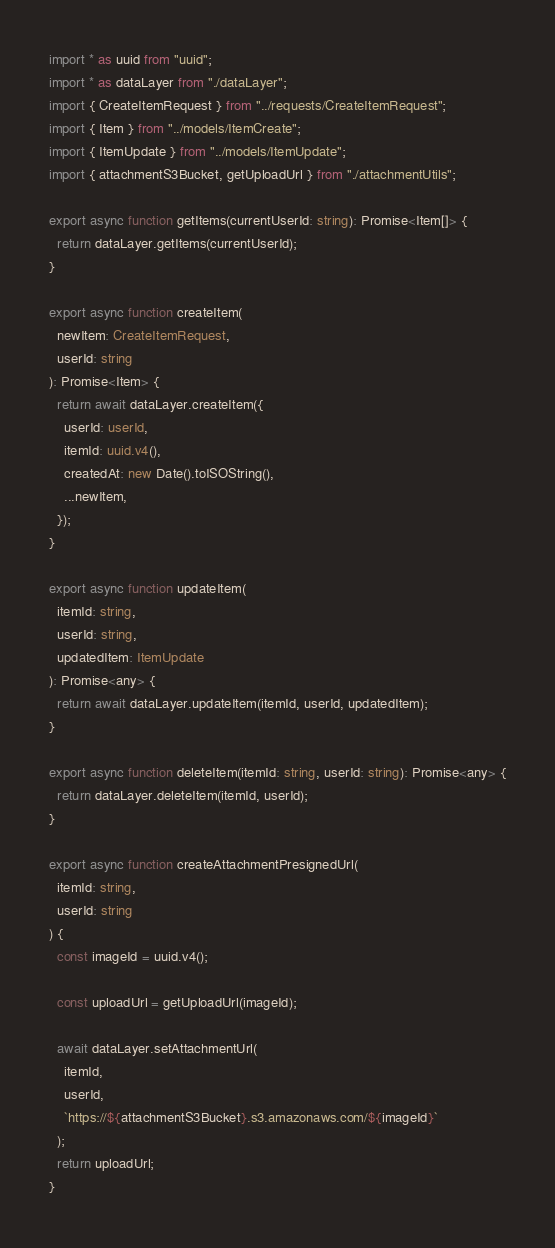Convert code to text. <code><loc_0><loc_0><loc_500><loc_500><_TypeScript_>import * as uuid from "uuid";
import * as dataLayer from "./dataLayer";
import { CreateItemRequest } from "../requests/CreateItemRequest";
import { Item } from "../models/ItemCreate";
import { ItemUpdate } from "../models/ItemUpdate";
import { attachmentS3Bucket, getUploadUrl } from "./attachmentUtils";

export async function getItems(currentUserId: string): Promise<Item[]> {
  return dataLayer.getItems(currentUserId);
}

export async function createItem(
  newItem: CreateItemRequest,
  userId: string
): Promise<Item> {
  return await dataLayer.createItem({
    userId: userId,
    itemId: uuid.v4(),
    createdAt: new Date().toISOString(),
    ...newItem,
  });
}

export async function updateItem(
  itemId: string,
  userId: string,
  updatedItem: ItemUpdate
): Promise<any> {
  return await dataLayer.updateItem(itemId, userId, updatedItem);
}

export async function deleteItem(itemId: string, userId: string): Promise<any> {
  return dataLayer.deleteItem(itemId, userId);
}

export async function createAttachmentPresignedUrl(
  itemId: string,
  userId: string
) {
  const imageId = uuid.v4();

  const uploadUrl = getUploadUrl(imageId);

  await dataLayer.setAttachmentUrl(
    itemId,
    userId,
    `https://${attachmentS3Bucket}.s3.amazonaws.com/${imageId}`
  );
  return uploadUrl;
}
</code> 